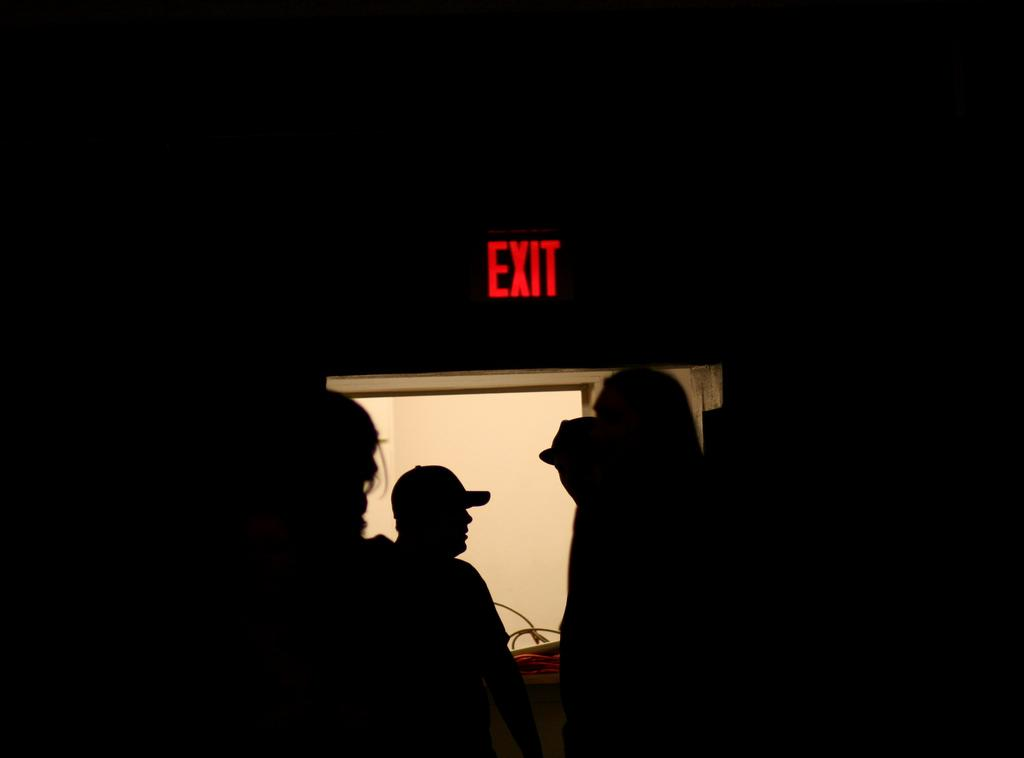How many people are in the image? There are people in the image, but the exact number is not specified. What is the exit board in the image used for? The exit board in the image is likely used for safety purposes, indicating the location of an exit. What is the color of the background in the image? The background of the image is dark. What type of form is being filled out by the people in the image? There is no form present in the image, and the people are not shown filling out any form. Can you see any dogs in the image? There is no mention of dogs in the image, and no dogs are visible. 